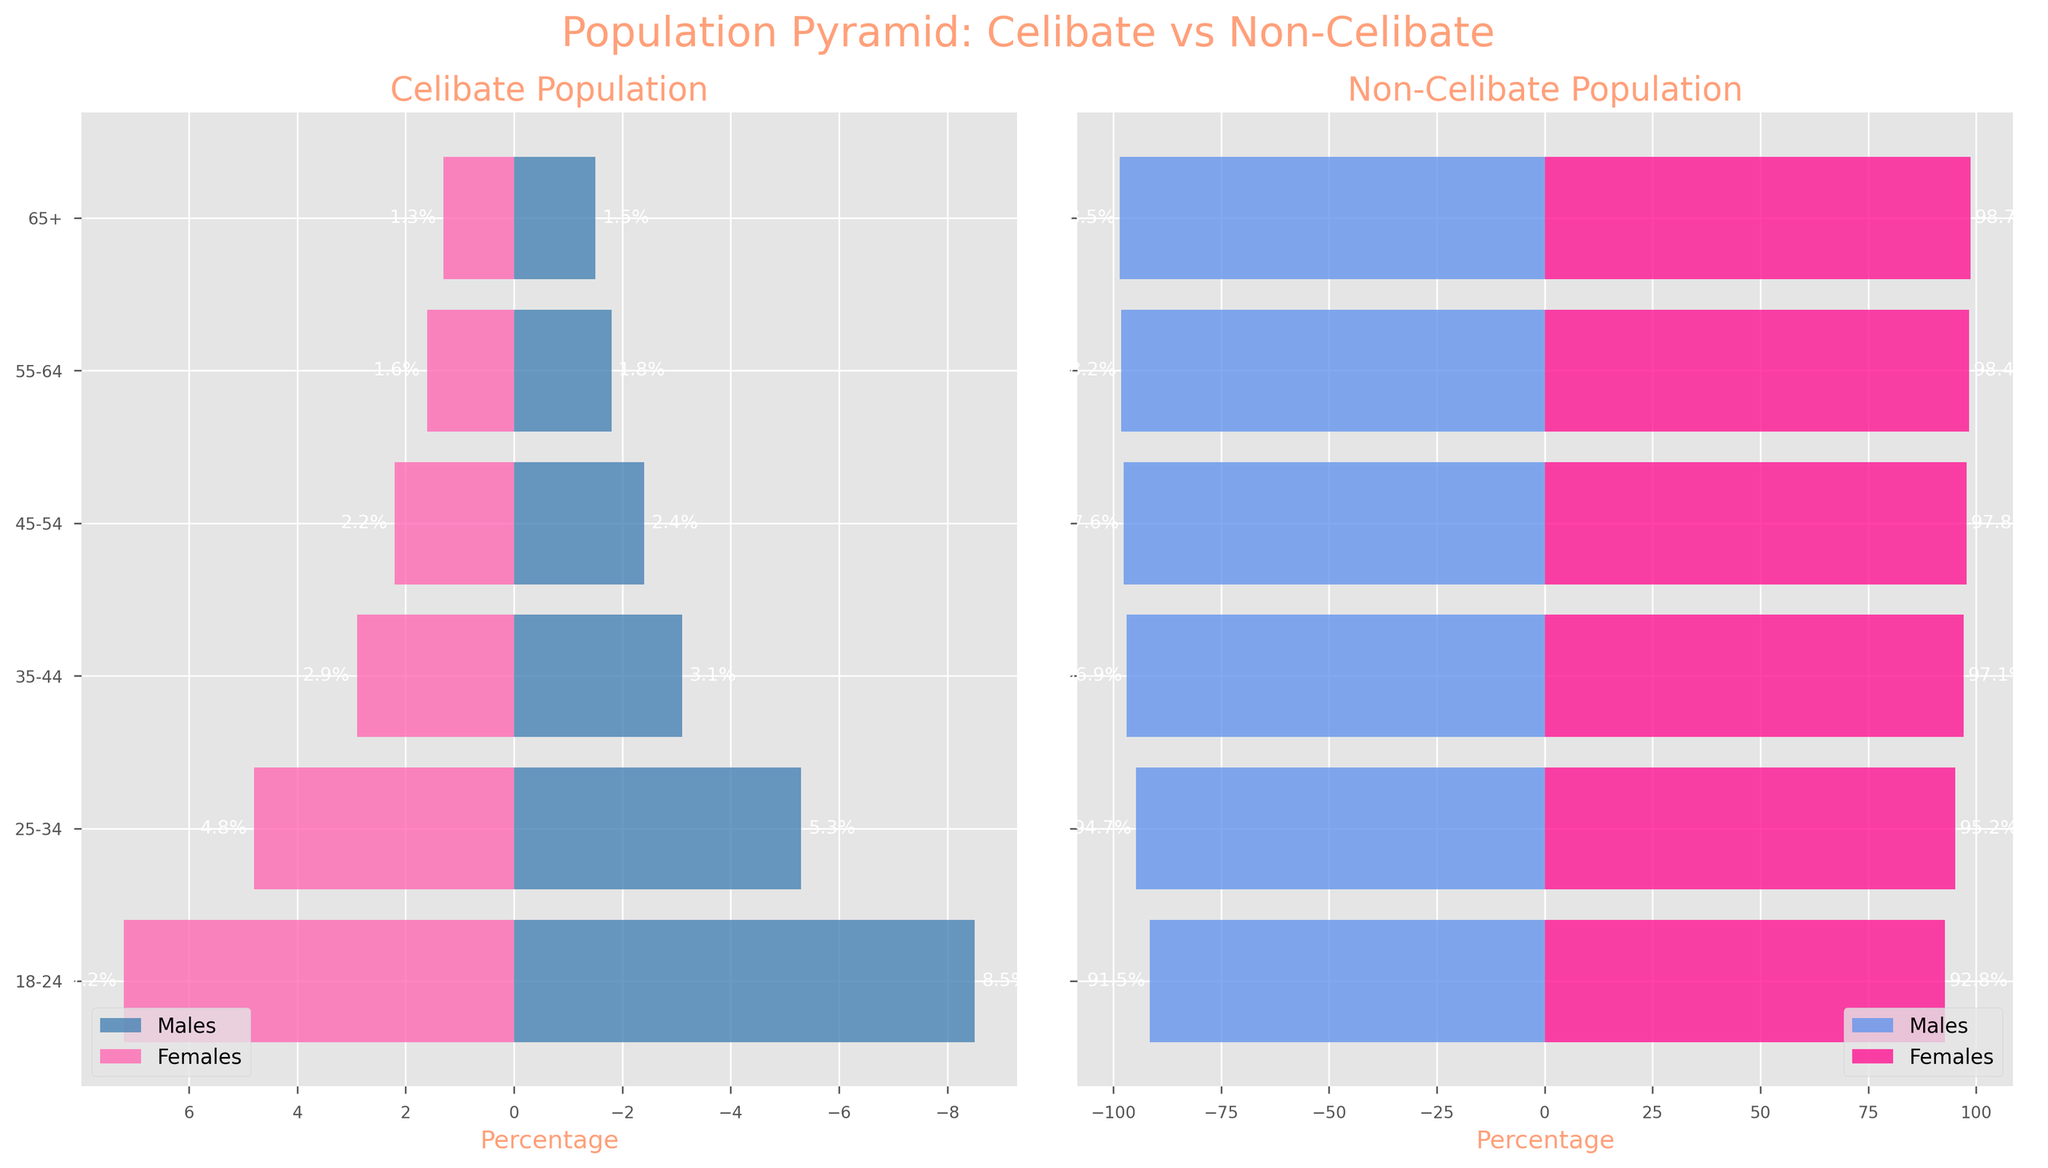What's the title of the figure? The title of the figure is usually located at the top and is centered. In this figure, you can see the title "Population Pyramid: Celibate vs Non-Celibate" at the top in a larger, bolder font.
Answer: Population Pyramid: Celibate vs Non-Celibate What are the axes' labels in this figure? In the figure, the axes' labels are located along the horizontal axes. The left-side plot has its x-axis labeled "Percentage", and the right-side plot also has its x-axis labeled "Percentage".
Answer: Percentage Which gender has a higher percentage in the celibate population within the 18-24 age group? By looking at the left plot (representing the celibate population), you can see the bars representing males and females within the 18-24 age group. The blue bar (males) is at 8.5%, and the pink bar (females) is at 7.2%. Therefore, the males have a higher percentage within this age group.
Answer: Males What is the trend of celibate males' percentage as the age increases? In the celibate population plot on the left, notice the lengths of the blue bars: 8.5%, 5.3%, 3.1%, 2.4%, 1.8%, and 1.5% from the youngest to the oldest age group. The percentage steadily decreases as the age increases.
Answer: Decreasing How does the percentage of non-celibate females in the 35-44 age group compare to that of celibate females in the same age group? To compare these, look at the non-celibate population plot on the right and find the corresponding bars for the 35-44 age group. Non-celibate females are at 97.1%, while celibate females in the left plot (for the same age group) are at 2.9%. There's a significant difference, with non-celibate females having a higher percentage.
Answer: Non-celibate females have a higher percentage than celibate females What is the combined percentage of celibate individuals (both genders) in the 25-34 age group? Sum the percentages of celibate males and females for the 25-34 age group: 5.3% (males) + 4.8% (females) = 10.1%.
Answer: 10.1% What is the percentage difference between non-celibate males and non-celibate females in the 55-64 age group? For the 55-64 age group in the non-celibate population plot:
- Non-celibate males: 98.2%
- Non-celibate females: 98.4%
Calculate the difference: 98.4% - 98.2% = 0.2%.
Answer: 0.2% What can you infer about the overall gender distribution for celibate individuals as they age? Observing the celibate population plot:
- The percentage of both males and females diminishes with age.
- Men's percentage tends to be slightly higher than women's across all age groups.
This suggests that fewer people identify as celibate as they get older, and it affects males slightly more.
Answer: Fewer celibates with age, males slightly higher 